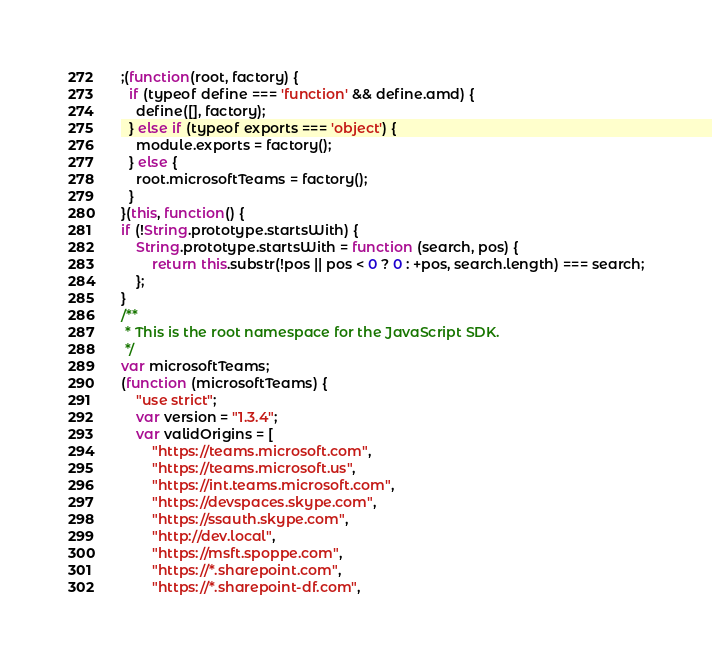<code> <loc_0><loc_0><loc_500><loc_500><_JavaScript_>;(function(root, factory) {
  if (typeof define === 'function' && define.amd) {
    define([], factory);
  } else if (typeof exports === 'object') {
    module.exports = factory();
  } else {
    root.microsoftTeams = factory();
  }
}(this, function() {
if (!String.prototype.startsWith) {
    String.prototype.startsWith = function (search, pos) {
        return this.substr(!pos || pos < 0 ? 0 : +pos, search.length) === search;
    };
}
/**
 * This is the root namespace for the JavaScript SDK.
 */
var microsoftTeams;
(function (microsoftTeams) {
    "use strict";
    var version = "1.3.4";
    var validOrigins = [
        "https://teams.microsoft.com",
        "https://teams.microsoft.us",
        "https://int.teams.microsoft.com",
        "https://devspaces.skype.com",
        "https://ssauth.skype.com",
        "http://dev.local",
        "https://msft.spoppe.com",
        "https://*.sharepoint.com",
        "https://*.sharepoint-df.com",</code> 